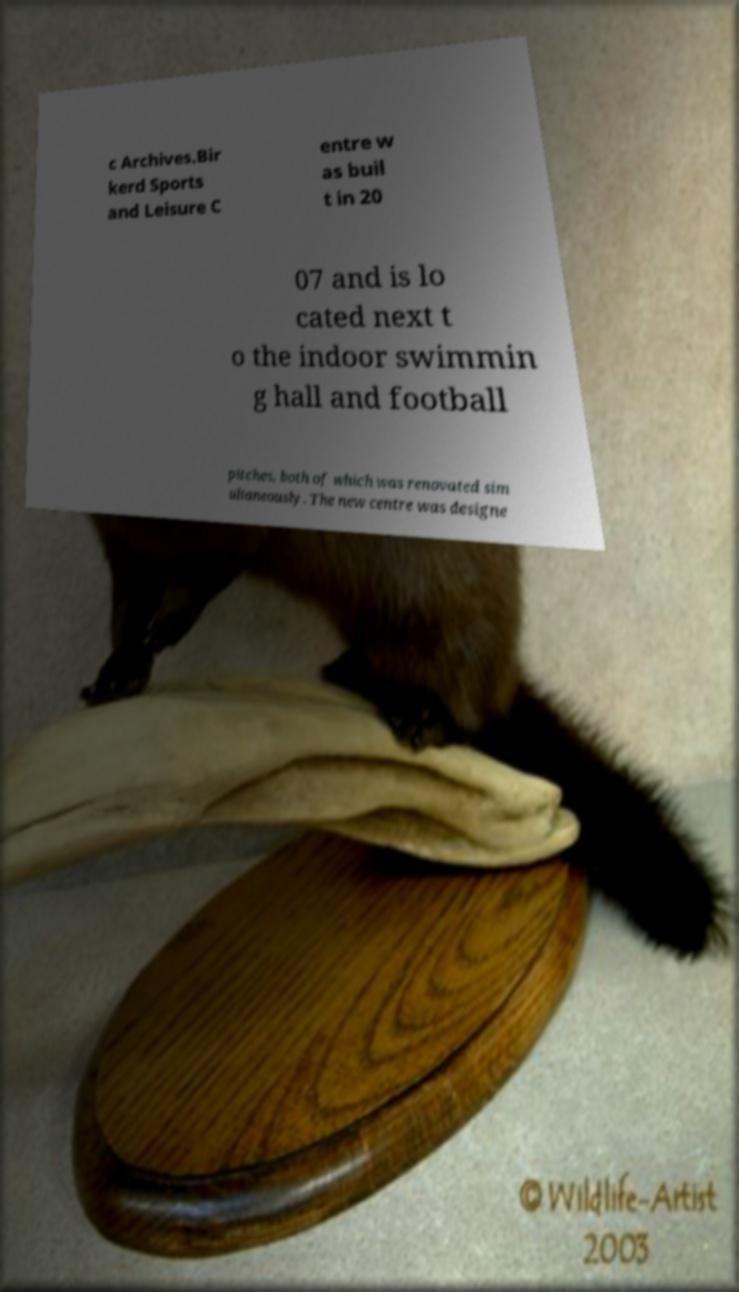For documentation purposes, I need the text within this image transcribed. Could you provide that? c Archives.Bir kerd Sports and Leisure C entre w as buil t in 20 07 and is lo cated next t o the indoor swimmin g hall and football pitches, both of which was renovated sim ultaneously. The new centre was designe 